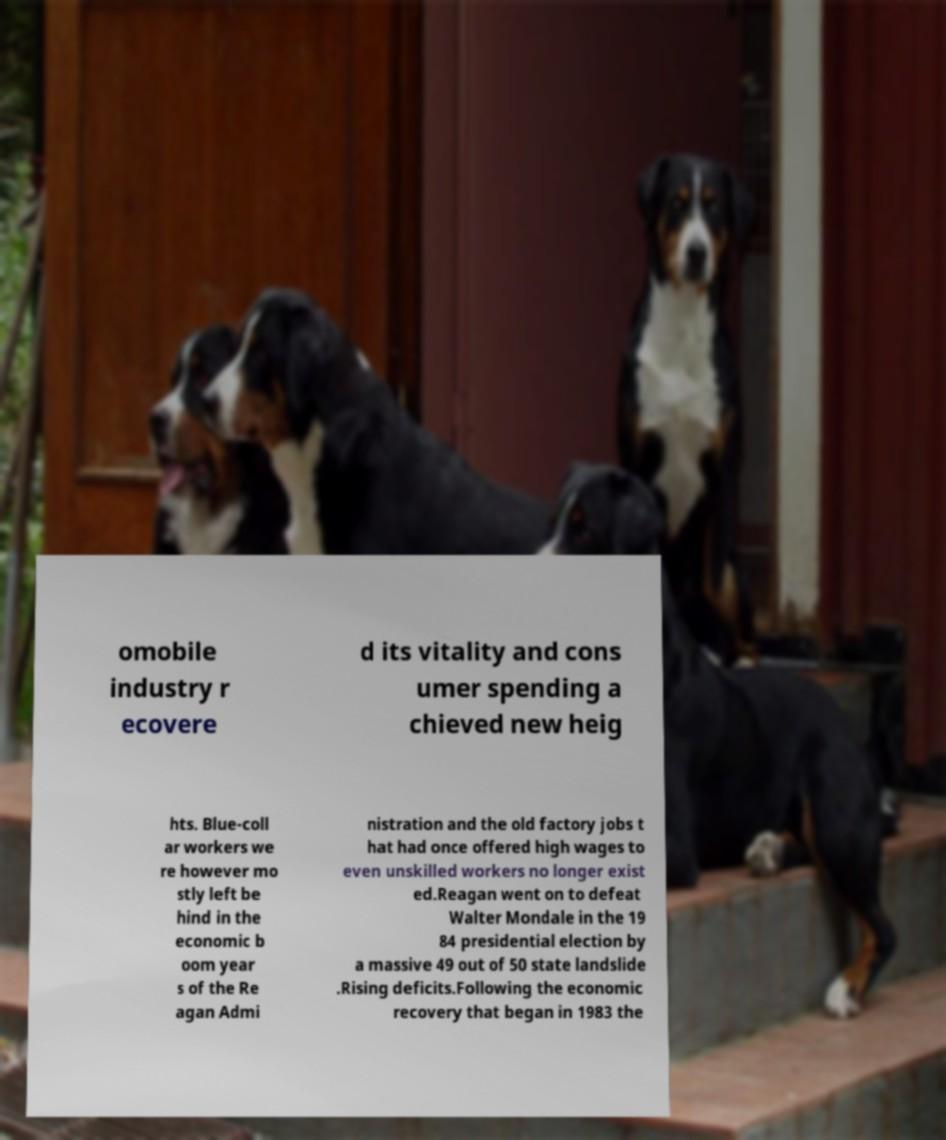Could you assist in decoding the text presented in this image and type it out clearly? omobile industry r ecovere d its vitality and cons umer spending a chieved new heig hts. Blue-coll ar workers we re however mo stly left be hind in the economic b oom year s of the Re agan Admi nistration and the old factory jobs t hat had once offered high wages to even unskilled workers no longer exist ed.Reagan went on to defeat Walter Mondale in the 19 84 presidential election by a massive 49 out of 50 state landslide .Rising deficits.Following the economic recovery that began in 1983 the 